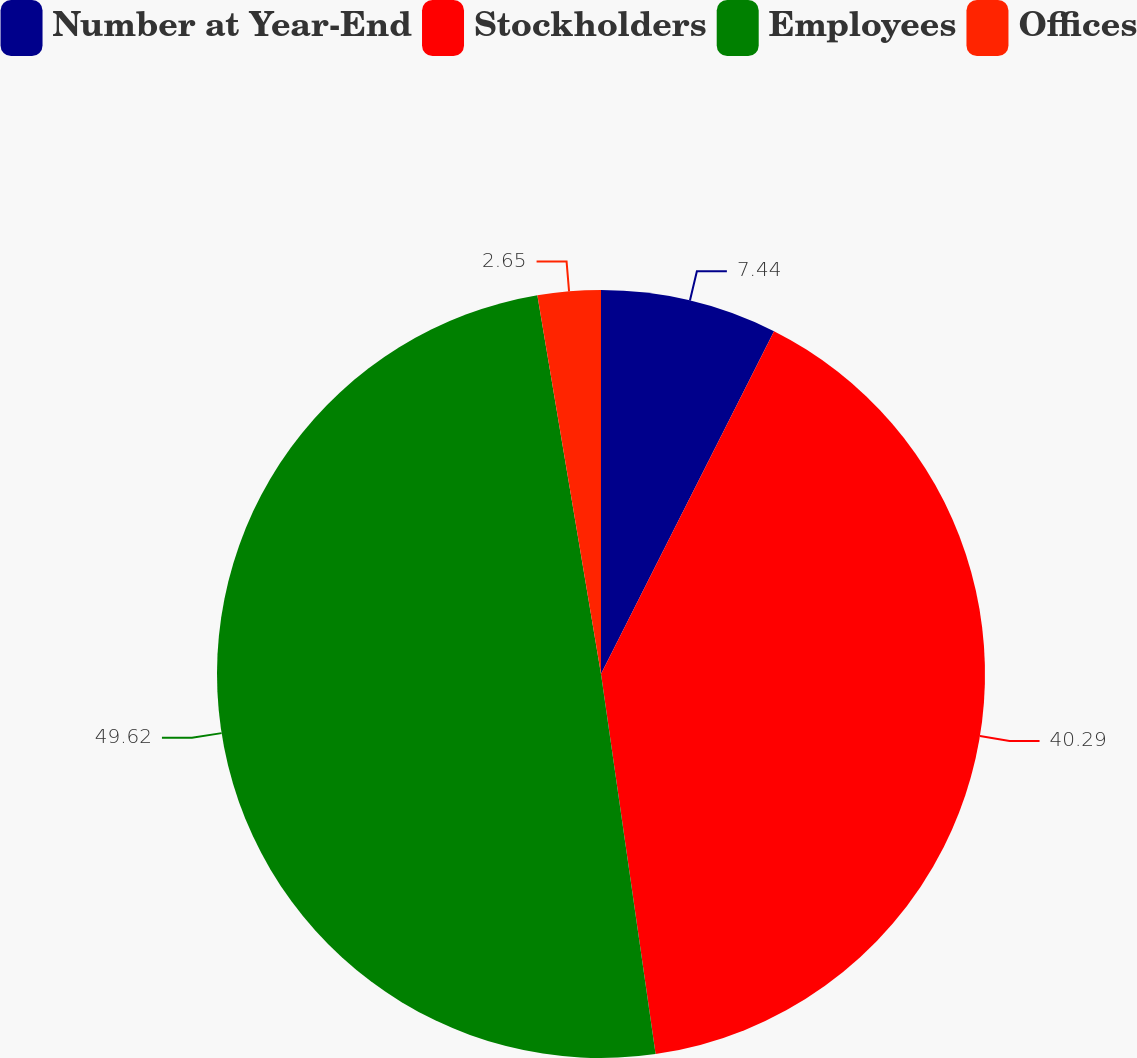<chart> <loc_0><loc_0><loc_500><loc_500><pie_chart><fcel>Number at Year-End<fcel>Stockholders<fcel>Employees<fcel>Offices<nl><fcel>7.44%<fcel>40.29%<fcel>49.62%<fcel>2.65%<nl></chart> 